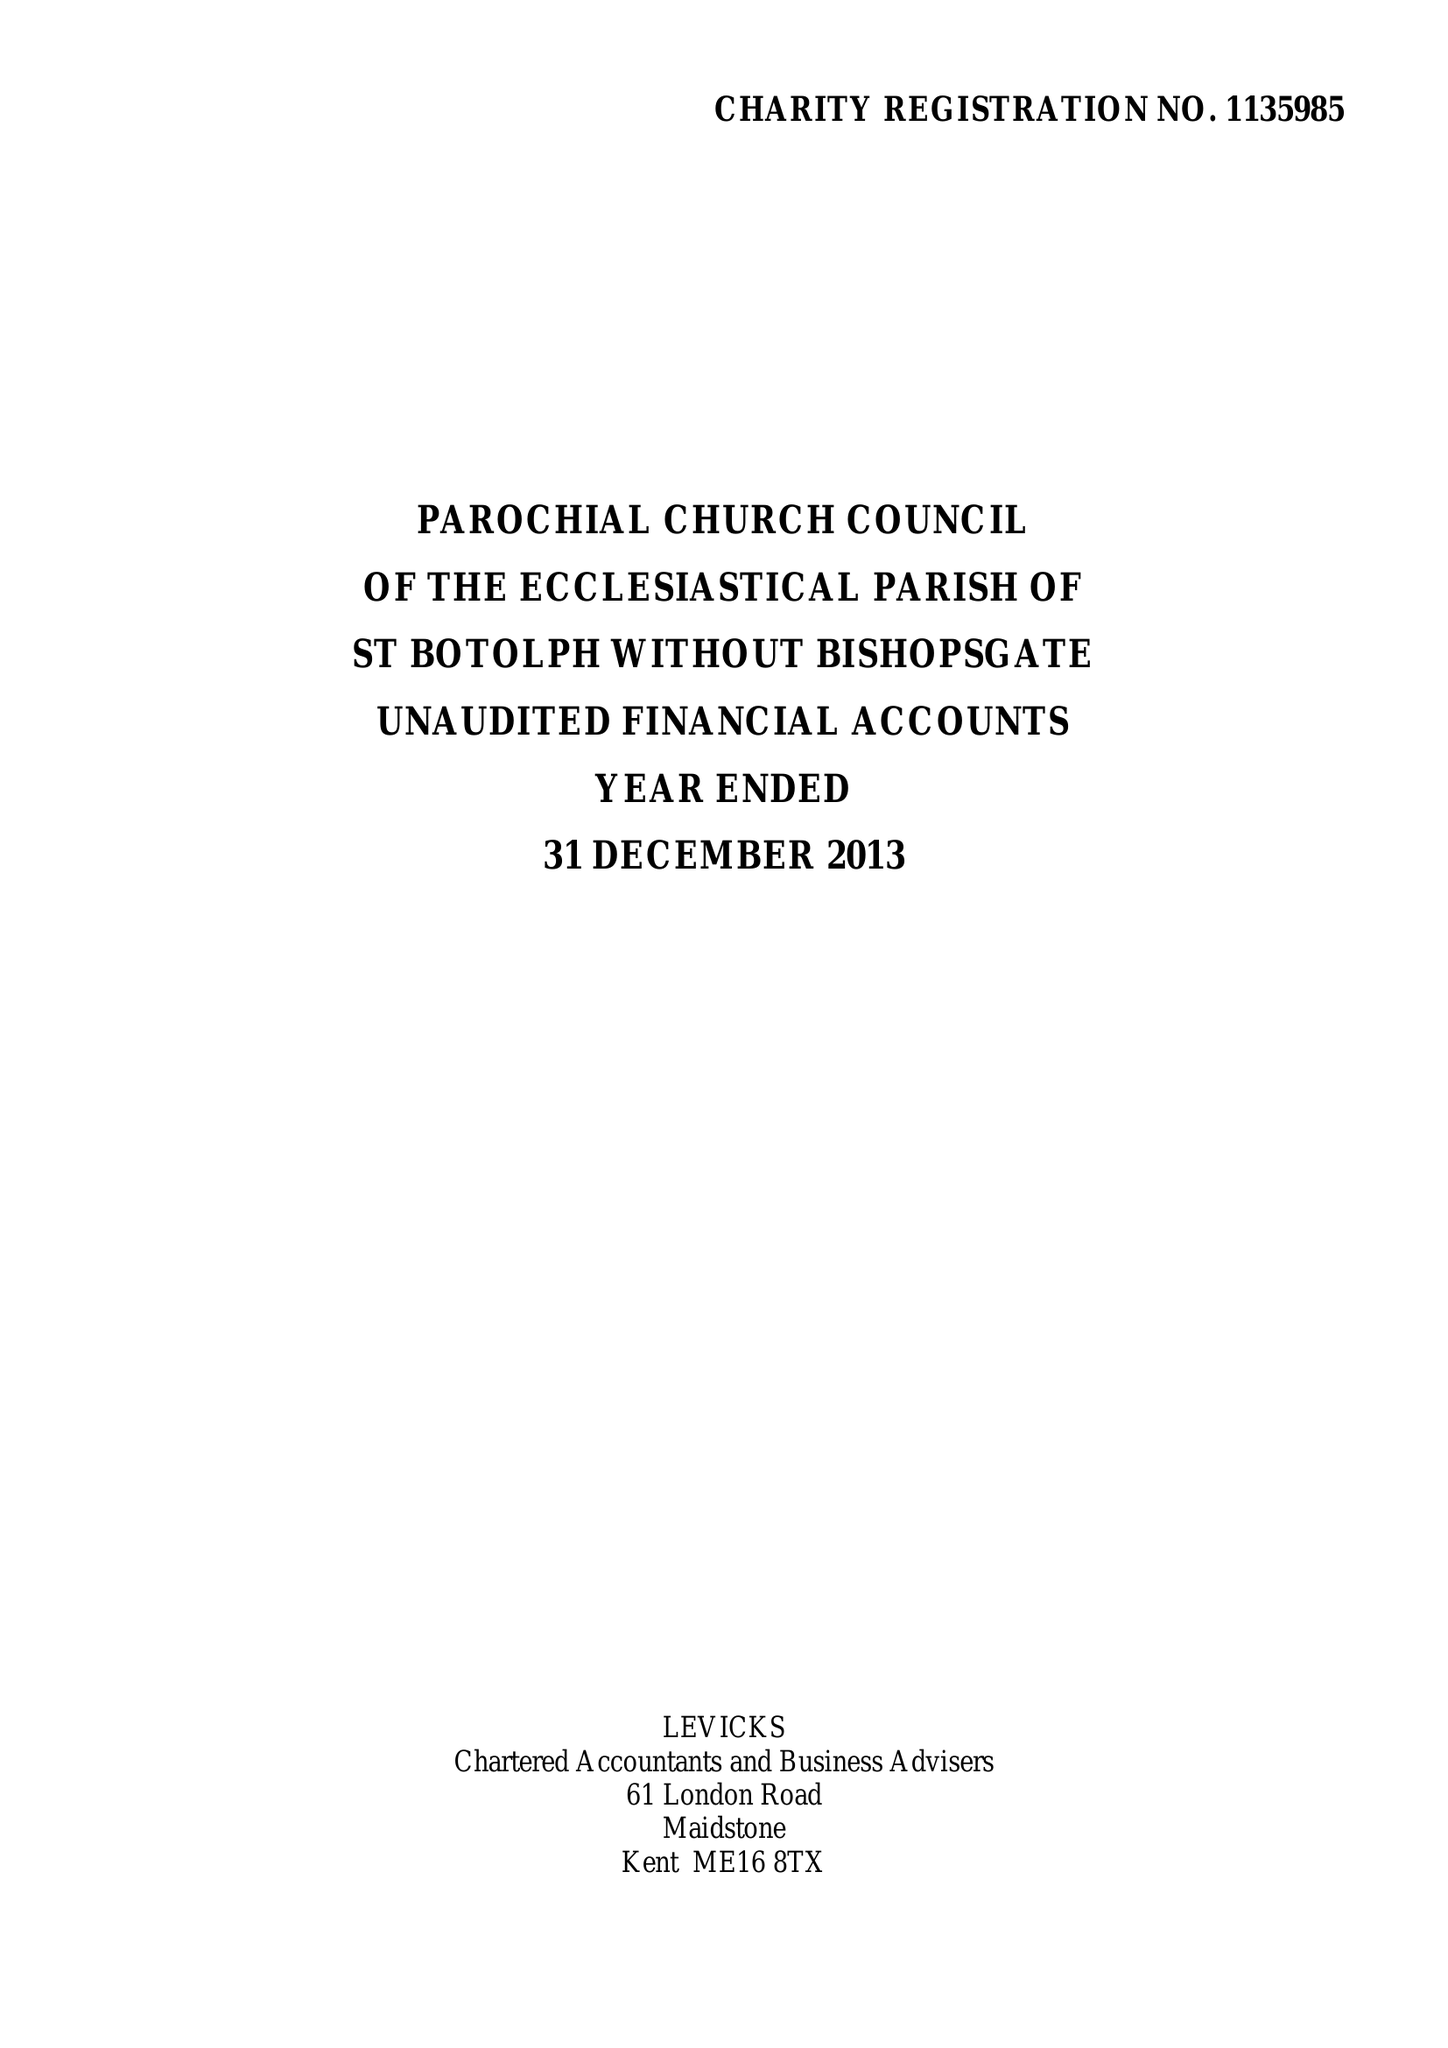What is the value for the charity_name?
Answer the question using a single word or phrase. The Parochial Church Council Of The Ecclesiastical Parish Of St Botolph-Without-Bishopsgate 